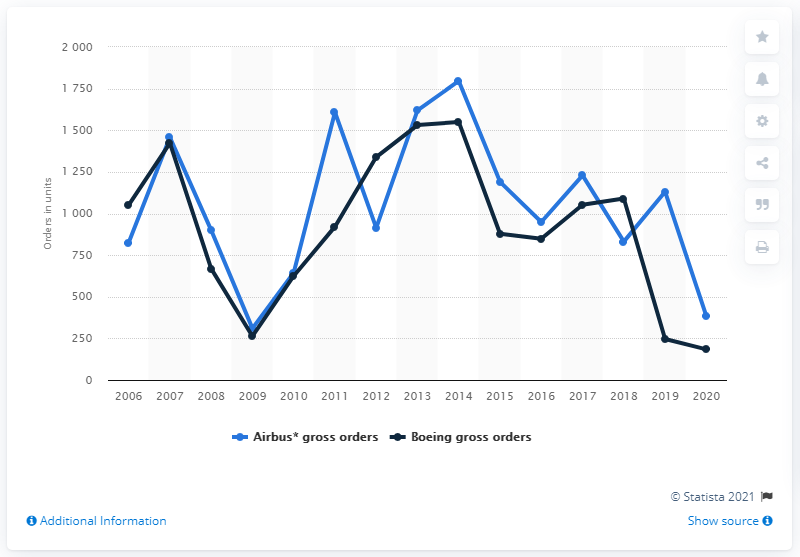Mention a couple of crucial points in this snapshot. Boeing received 246 gross orders in 2020. In 2020, Airbus received a total of 184 gross orders. 